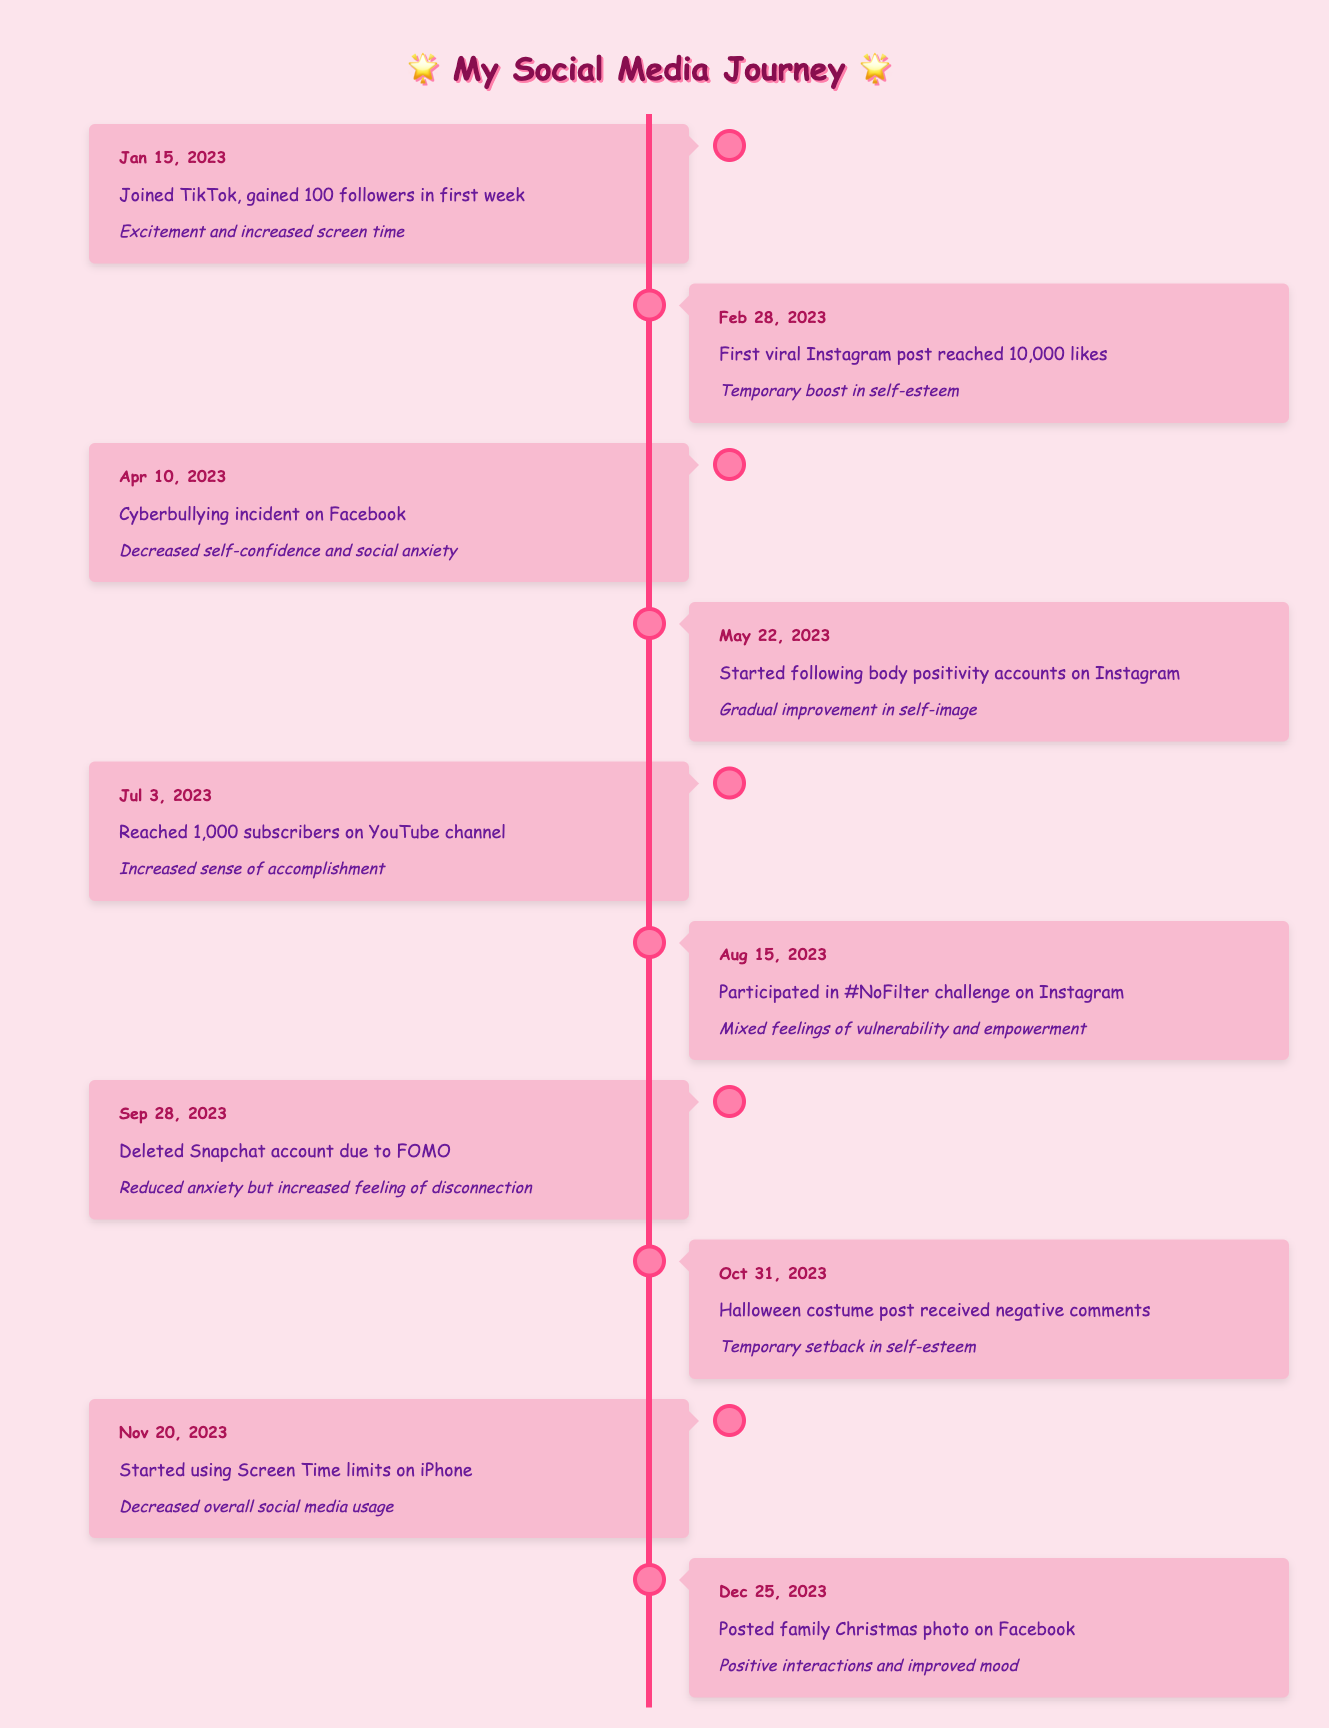What event occurred on April 10, 2023? The table shows the event on April 10, 2023, as a cyberbullying incident on Facebook.
Answer: Cyberbullying incident on Facebook How many likes did the first viral Instagram post receive? According to the table, the first viral Instagram post reached 10,000 likes on February 28, 2023.
Answer: 10,000 likes Did the usage of Screen Time limits on the iPhone have a positive impact on social media usage? The table indicates that starting on November 20, 2023, using Screen Time limits resulted in decreased overall social media usage, suggesting a positive impact.
Answer: Yes What was the impact of deleting the Snapchat account on September 28, 2023? The table states that deleting the Snapchat account led to reduced anxiety but increased feelings of disconnection, detailing the mixed effects of this decision.
Answer: Reduced anxiety, increased disconnection Which social media platform was associated with a temporary boost in self-esteem? The table notes that the first viral post on Instagram on February 28, 2023, resulted in a temporary boost in self-esteem.
Answer: Instagram What is the average number of followers or subscribers gained from January to July 2023? To find the average, sum the followers (100 from TikTok) and subscribers (1,000 from YouTube), giving a total of 1,100, and divide by 2, resulting in an average of 550.
Answer: 550 Was there a negative comment related to a Halloween costume post? Yes, the table indicates that on October 31, 2023, the Halloween costume post received negative comments.
Answer: Yes How did following body positivity accounts on Instagram affect self-image? The table states that following body positivity accounts starting on May 22, 2023, led to a gradual improvement in self-image, highlighting a positive influence.
Answer: Gradual improvement in self-image What was the event on December 25, 2023, and what was the impact? The event on December 25, 2023, involved posting a family Christmas photo on Facebook, resulting in positive interactions and improved mood, showcasing a beneficial outcome.
Answer: Posted family Christmas photo, positive interactions and improved mood 